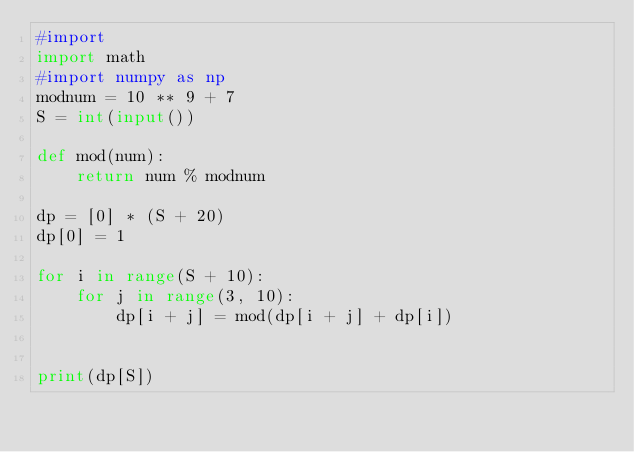Convert code to text. <code><loc_0><loc_0><loc_500><loc_500><_Python_>#import
import math
#import numpy as np
modnum = 10 ** 9 + 7
S = int(input())

def mod(num):
    return num % modnum

dp = [0] * (S + 20)
dp[0] = 1

for i in range(S + 10):
    for j in range(3, 10):
        dp[i + j] = mod(dp[i + j] + dp[i])


print(dp[S])


</code> 